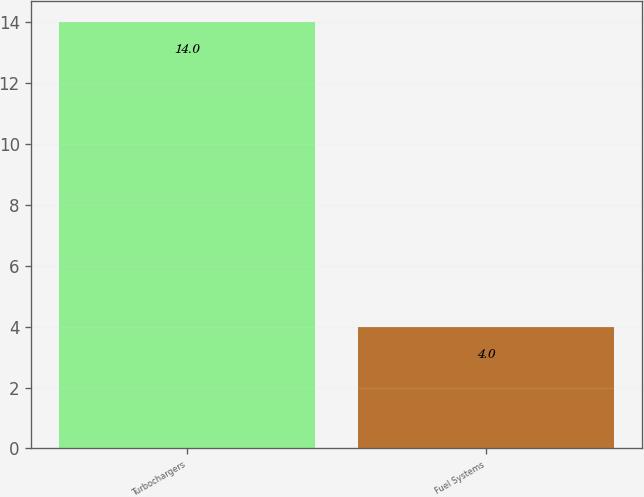<chart> <loc_0><loc_0><loc_500><loc_500><bar_chart><fcel>Turbochargers<fcel>Fuel Systems<nl><fcel>14<fcel>4<nl></chart> 